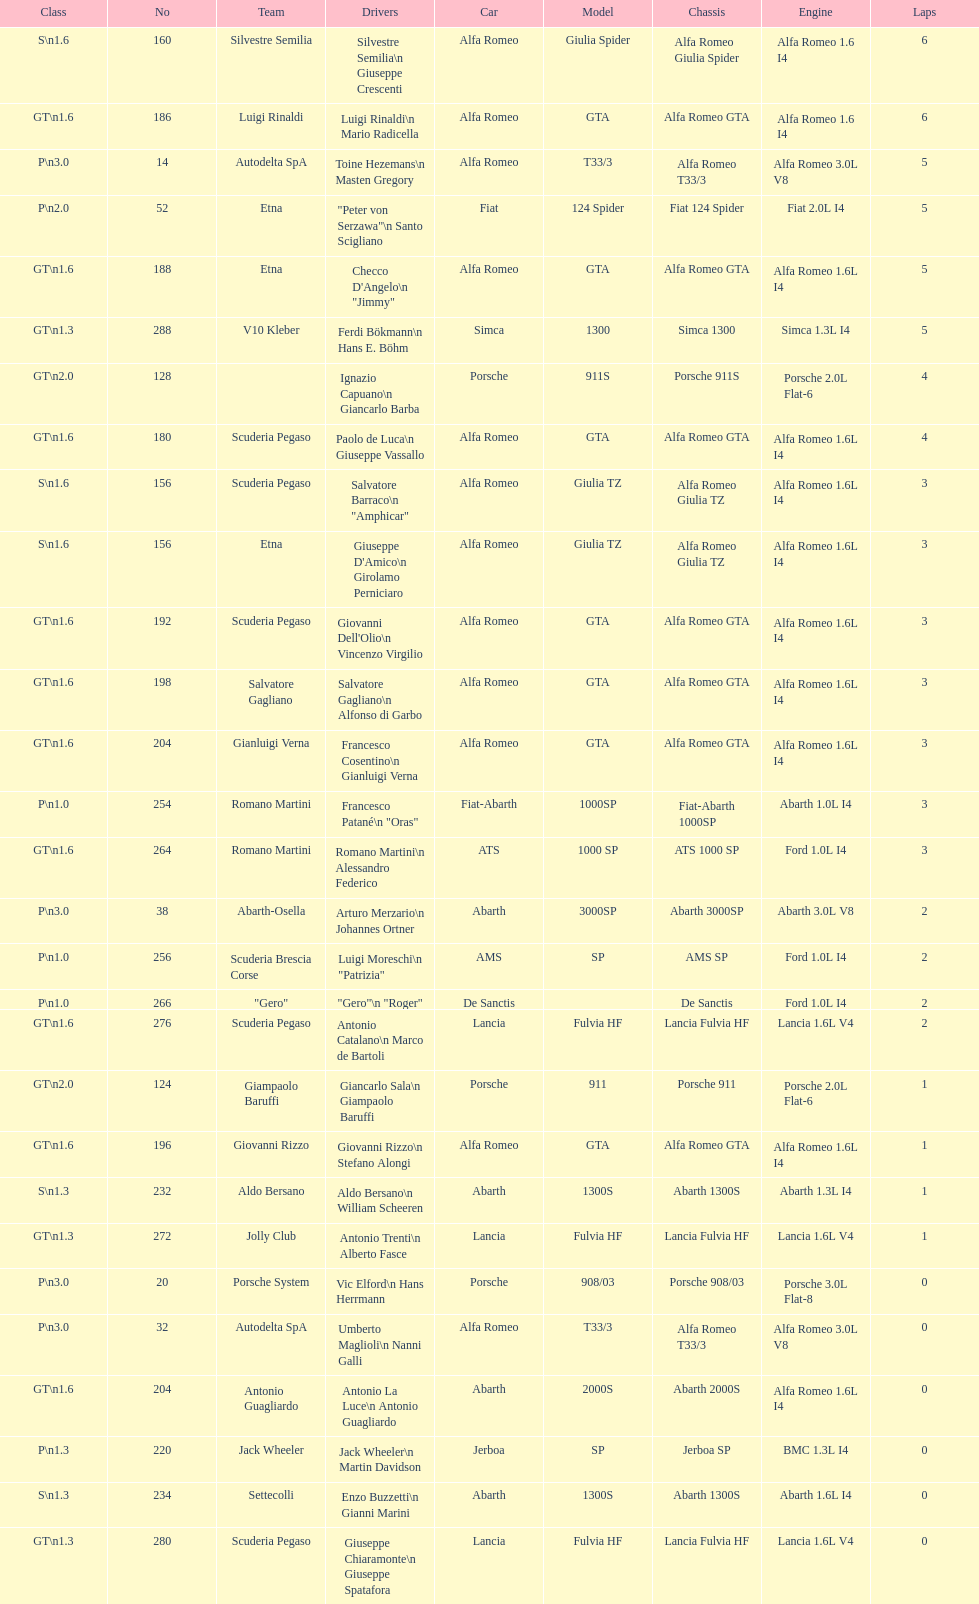Name the only american who did not finish the race. Masten Gregory. 